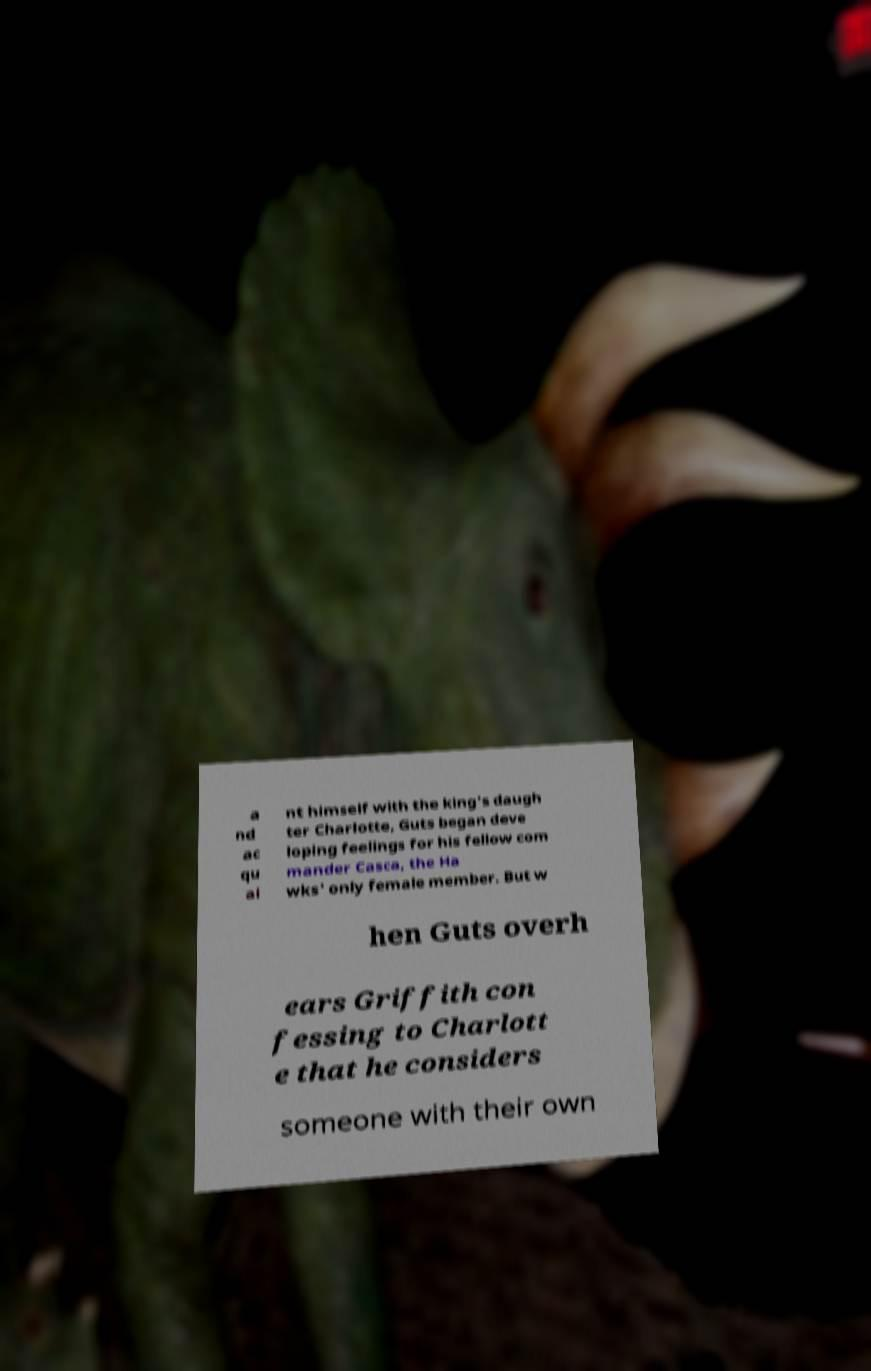Please read and relay the text visible in this image. What does it say? a nd ac qu ai nt himself with the king's daugh ter Charlotte, Guts began deve loping feelings for his fellow com mander Casca, the Ha wks' only female member. But w hen Guts overh ears Griffith con fessing to Charlott e that he considers someone with their own 